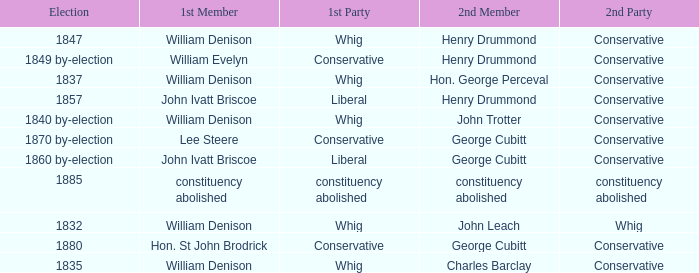Parse the full table. {'header': ['Election', '1st Member', '1st Party', '2nd Member', '2nd Party'], 'rows': [['1847', 'William Denison', 'Whig', 'Henry Drummond', 'Conservative'], ['1849 by-election', 'William Evelyn', 'Conservative', 'Henry Drummond', 'Conservative'], ['1837', 'William Denison', 'Whig', 'Hon. George Perceval', 'Conservative'], ['1857', 'John Ivatt Briscoe', 'Liberal', 'Henry Drummond', 'Conservative'], ['1840 by-election', 'William Denison', 'Whig', 'John Trotter', 'Conservative'], ['1870 by-election', 'Lee Steere', 'Conservative', 'George Cubitt', 'Conservative'], ['1860 by-election', 'John Ivatt Briscoe', 'Liberal', 'George Cubitt', 'Conservative'], ['1885', 'constituency abolished', 'constituency abolished', 'constituency abolished', 'constituency abolished'], ['1832', 'William Denison', 'Whig', 'John Leach', 'Whig'], ['1880', 'Hon. St John Brodrick', 'Conservative', 'George Cubitt', 'Conservative'], ['1835', 'William Denison', 'Whig', 'Charles Barclay', 'Conservative']]} Which party's 1st member is John Ivatt Briscoe in an election in 1857? Liberal. 